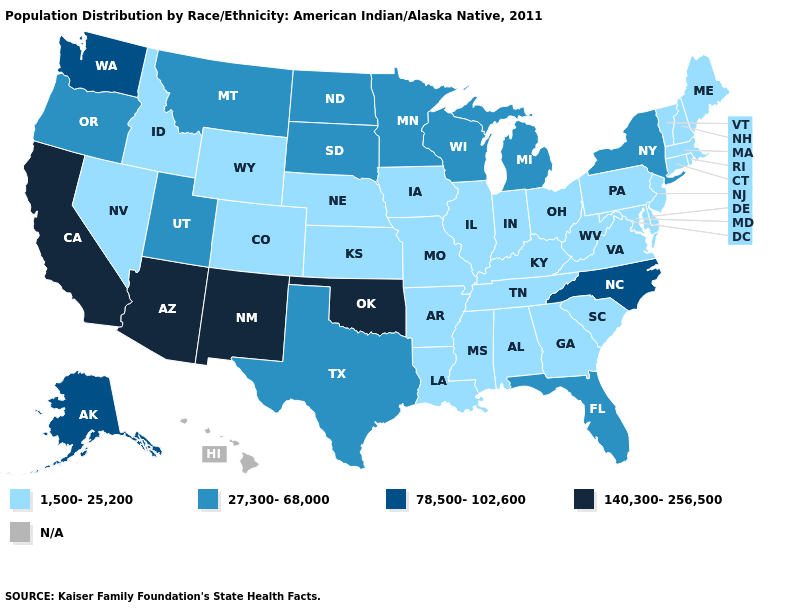Which states have the lowest value in the Northeast?
Concise answer only. Connecticut, Maine, Massachusetts, New Hampshire, New Jersey, Pennsylvania, Rhode Island, Vermont. What is the value of Nevada?
Write a very short answer. 1,500-25,200. Name the states that have a value in the range 27,300-68,000?
Write a very short answer. Florida, Michigan, Minnesota, Montana, New York, North Dakota, Oregon, South Dakota, Texas, Utah, Wisconsin. What is the value of Michigan?
Short answer required. 27,300-68,000. What is the value of Idaho?
Short answer required. 1,500-25,200. What is the value of Oklahoma?
Quick response, please. 140,300-256,500. What is the highest value in the MidWest ?
Give a very brief answer. 27,300-68,000. What is the value of New York?
Concise answer only. 27,300-68,000. Name the states that have a value in the range 1,500-25,200?
Be succinct. Alabama, Arkansas, Colorado, Connecticut, Delaware, Georgia, Idaho, Illinois, Indiana, Iowa, Kansas, Kentucky, Louisiana, Maine, Maryland, Massachusetts, Mississippi, Missouri, Nebraska, Nevada, New Hampshire, New Jersey, Ohio, Pennsylvania, Rhode Island, South Carolina, Tennessee, Vermont, Virginia, West Virginia, Wyoming. Name the states that have a value in the range 78,500-102,600?
Quick response, please. Alaska, North Carolina, Washington. What is the value of Minnesota?
Give a very brief answer. 27,300-68,000. Among the states that border New Mexico , which have the lowest value?
Write a very short answer. Colorado. 